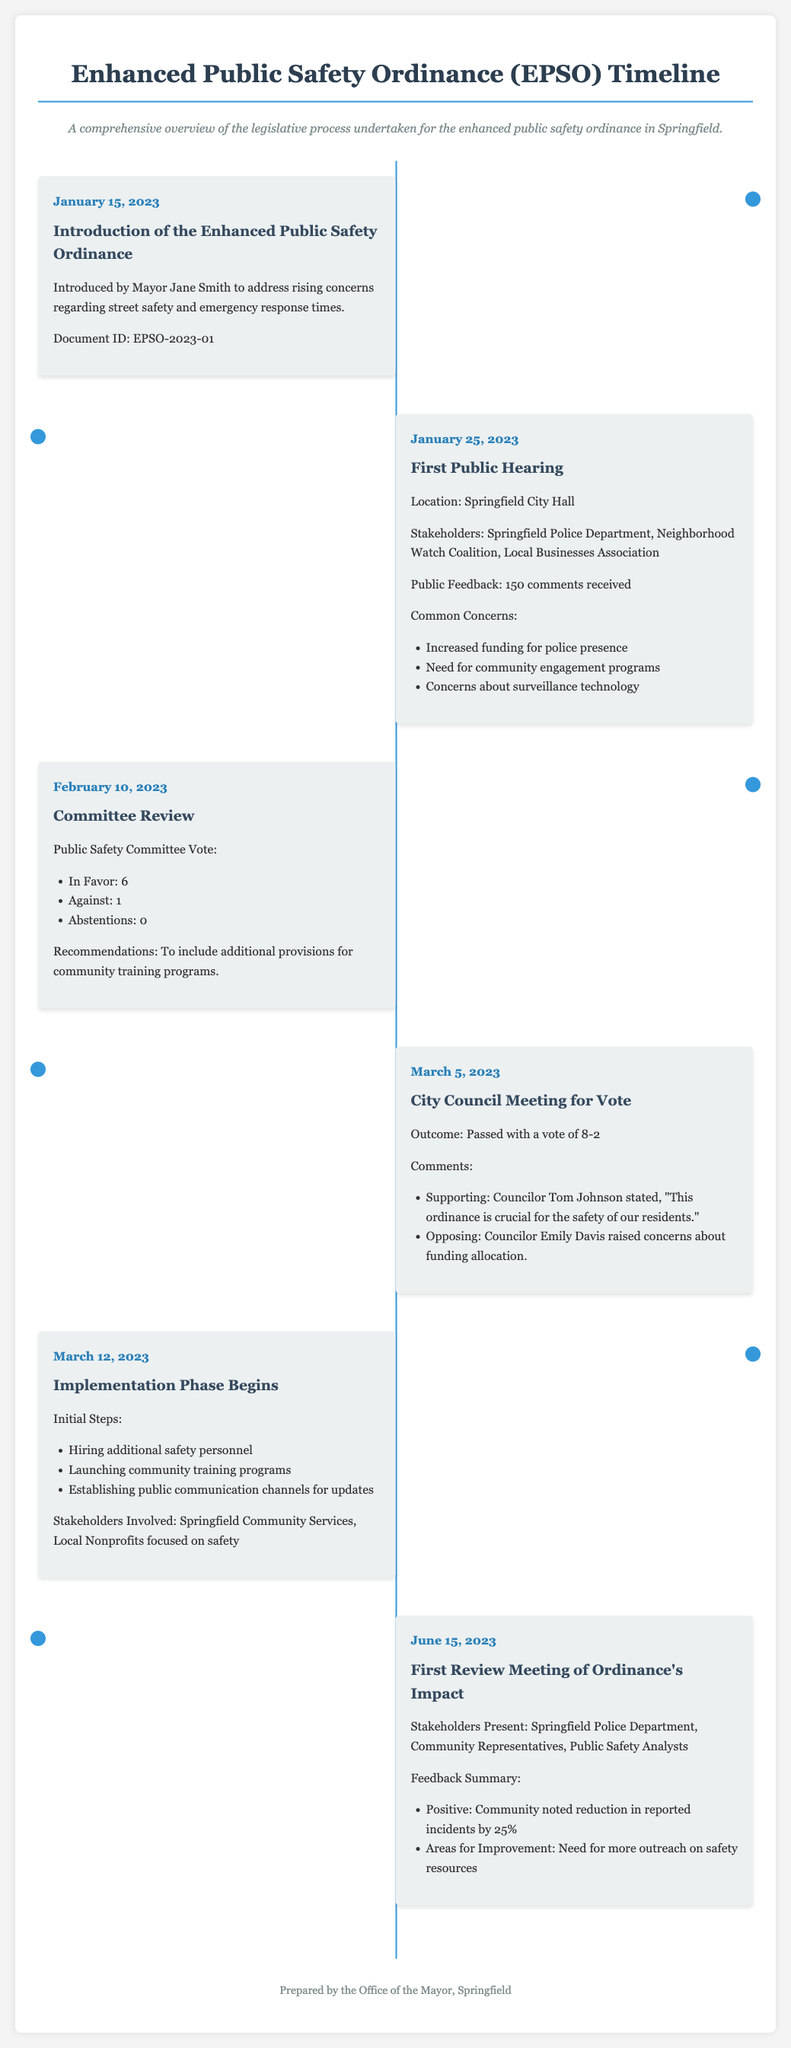What is the date of the first public hearing? The date is explicitly mentioned in the timeline section as January 25, 2023.
Answer: January 25, 2023 Who introduced the Enhanced Public Safety Ordinance? The document states the ordinance was introduced by Mayor Jane Smith.
Answer: Mayor Jane Smith What was the outcome of the City Council Meeting vote? The voting outcome is detailed in the event section, and it states that the ordinance passed with a vote of 8-2.
Answer: Passed with a vote of 8-2 How many comments were received during the first public hearing? The number of comments received is listed as 150 in the feedback section of the timeline.
Answer: 150 What percentage reduction in reported incidents was noted in the first review meeting? The document indicates that a 25% reduction in reported incidents was noted.
Answer: 25% What specific recommendation did the Public Safety Committee make? The recommendations related to including additional provisions for community training programs are highlighted in the committee review section.
Answer: Additional provisions for community training programs When did the implementation phase begin? The document specifies the implementation phase began on March 12, 2023.
Answer: March 12, 2023 Which stakeholders were involved in the first review meeting? The stakeholders present included the Springfield Police Department, Community Representatives, and Public Safety Analysts.
Answer: Springfield Police Department, Community Representatives, Public Safety Analysts What common concern was raised during the first public hearing regarding technology? A specific concern related to surveillance technology was mentioned in the summary of public feedback.
Answer: Surveillance technology 